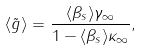Convert formula to latex. <formula><loc_0><loc_0><loc_500><loc_500>\langle \tilde { g } \rangle = \frac { \langle \beta _ { s } \rangle \gamma _ { \infty } } { 1 - \langle \beta _ { s } \rangle \kappa _ { \infty } } ,</formula> 